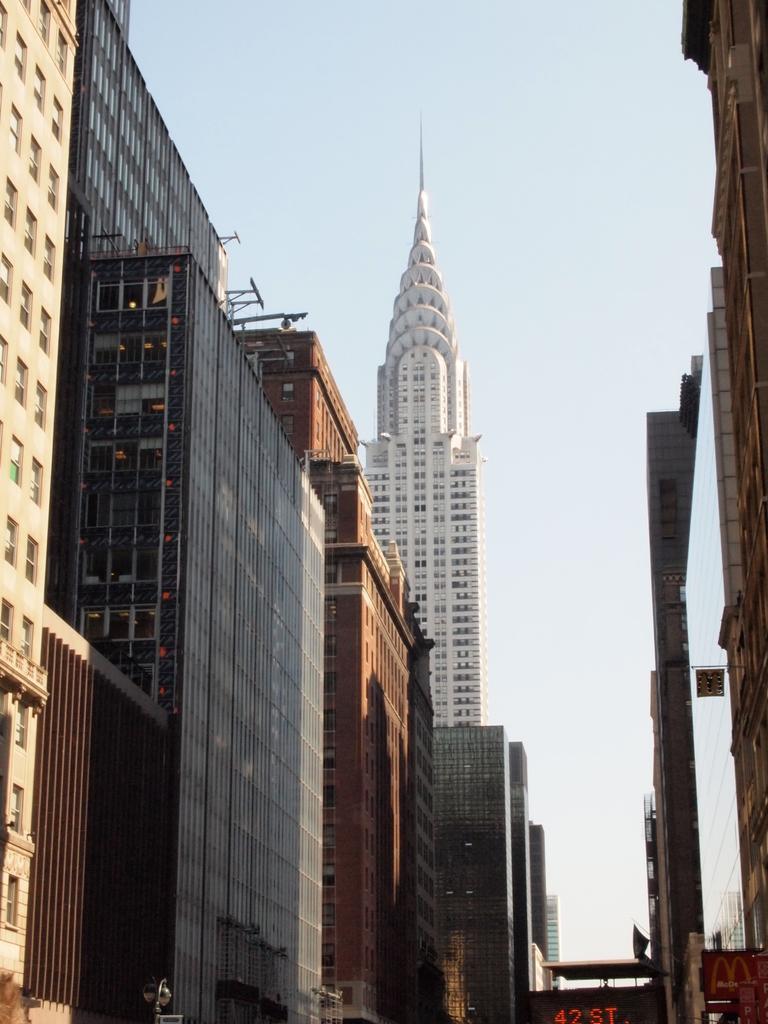Describe this image in one or two sentences. In this picture I can see number of buildings in front and in the background I can see the clear sky. 